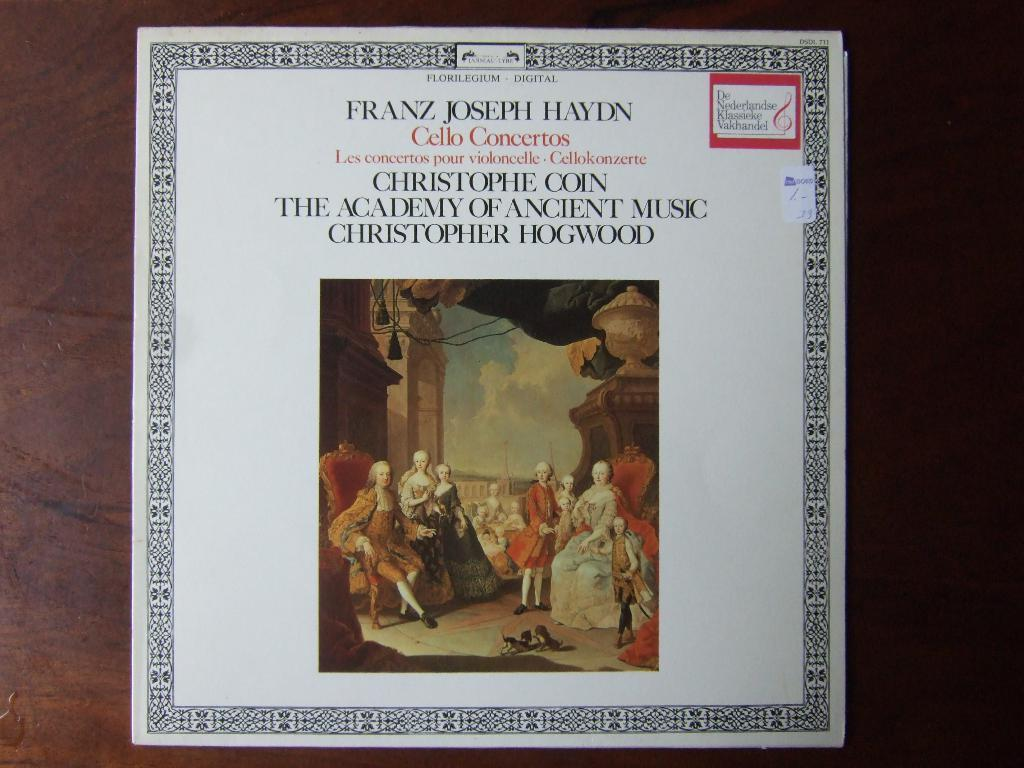Provide a one-sentence caption for the provided image. A picture with the name Franz Joseph Haydn at the top. 